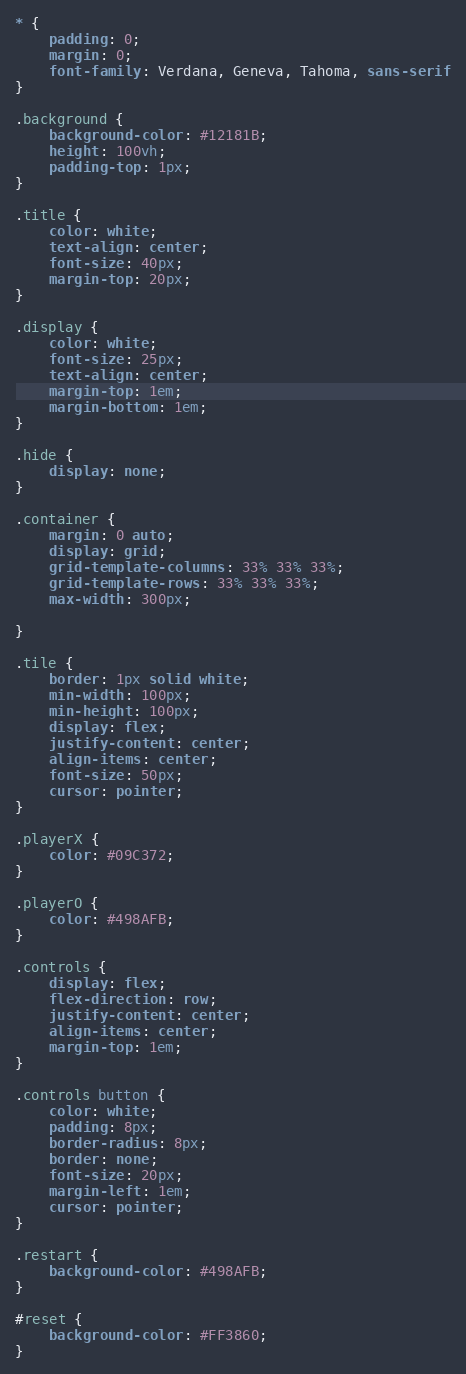Convert code to text. <code><loc_0><loc_0><loc_500><loc_500><_CSS_>* {
    padding: 0;
    margin: 0;
    font-family: Verdana, Geneva, Tahoma, sans-serif
}

.background {
    background-color: #12181B;
    height: 100vh;
    padding-top: 1px;
}

.title {
    color: white;
    text-align: center;
    font-size: 40px;
    margin-top: 20px;
}

.display {
    color: white;
    font-size: 25px;
    text-align: center;
    margin-top: 1em;
    margin-bottom: 1em;
}

.hide {
    display: none;
}

.container {
    margin: 0 auto;
    display: grid;
    grid-template-columns: 33% 33% 33%;
    grid-template-rows: 33% 33% 33%;
    max-width: 300px;

}

.tile {
    border: 1px solid white;
    min-width: 100px;
    min-height: 100px;
    display: flex;
    justify-content: center;
    align-items: center;
    font-size: 50px;
    cursor: pointer;
}

.playerX {
    color: #09C372;
}

.playerO {
    color: #498AFB;
}

.controls {
    display: flex;
    flex-direction: row;
    justify-content: center;
    align-items: center;
    margin-top: 1em;
}

.controls button {
    color: white;
    padding: 8px;
    border-radius: 8px;
    border: none;
    font-size: 20px;
    margin-left: 1em;
    cursor: pointer;
}

.restart {
    background-color: #498AFB;
}

#reset {
    background-color: #FF3860;
}</code> 